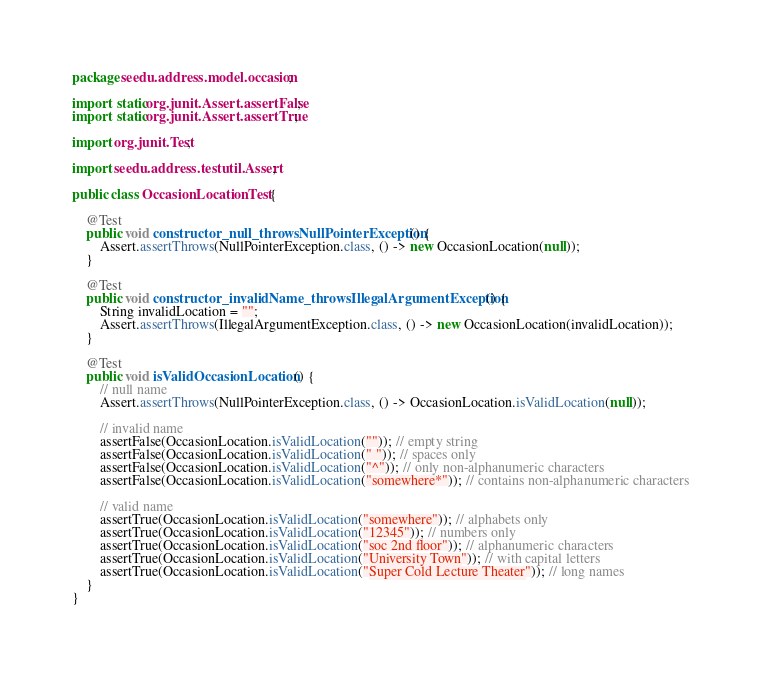Convert code to text. <code><loc_0><loc_0><loc_500><loc_500><_Java_>package seedu.address.model.occasion;

import static org.junit.Assert.assertFalse;
import static org.junit.Assert.assertTrue;

import org.junit.Test;

import seedu.address.testutil.Assert;

public class OccasionLocationTest {

    @Test
    public void constructor_null_throwsNullPointerException() {
        Assert.assertThrows(NullPointerException.class, () -> new OccasionLocation(null));
    }

    @Test
    public void constructor_invalidName_throwsIllegalArgumentException() {
        String invalidLocation = "";
        Assert.assertThrows(IllegalArgumentException.class, () -> new OccasionLocation(invalidLocation));
    }

    @Test
    public void isValidOccasionLocation() {
        // null name
        Assert.assertThrows(NullPointerException.class, () -> OccasionLocation.isValidLocation(null));

        // invalid name
        assertFalse(OccasionLocation.isValidLocation("")); // empty string
        assertFalse(OccasionLocation.isValidLocation(" ")); // spaces only
        assertFalse(OccasionLocation.isValidLocation("^")); // only non-alphanumeric characters
        assertFalse(OccasionLocation.isValidLocation("somewhere*")); // contains non-alphanumeric characters

        // valid name
        assertTrue(OccasionLocation.isValidLocation("somewhere")); // alphabets only
        assertTrue(OccasionLocation.isValidLocation("12345")); // numbers only
        assertTrue(OccasionLocation.isValidLocation("soc 2nd floor")); // alphanumeric characters
        assertTrue(OccasionLocation.isValidLocation("University Town")); // with capital letters
        assertTrue(OccasionLocation.isValidLocation("Super Cold Lecture Theater")); // long names
    }
}
</code> 